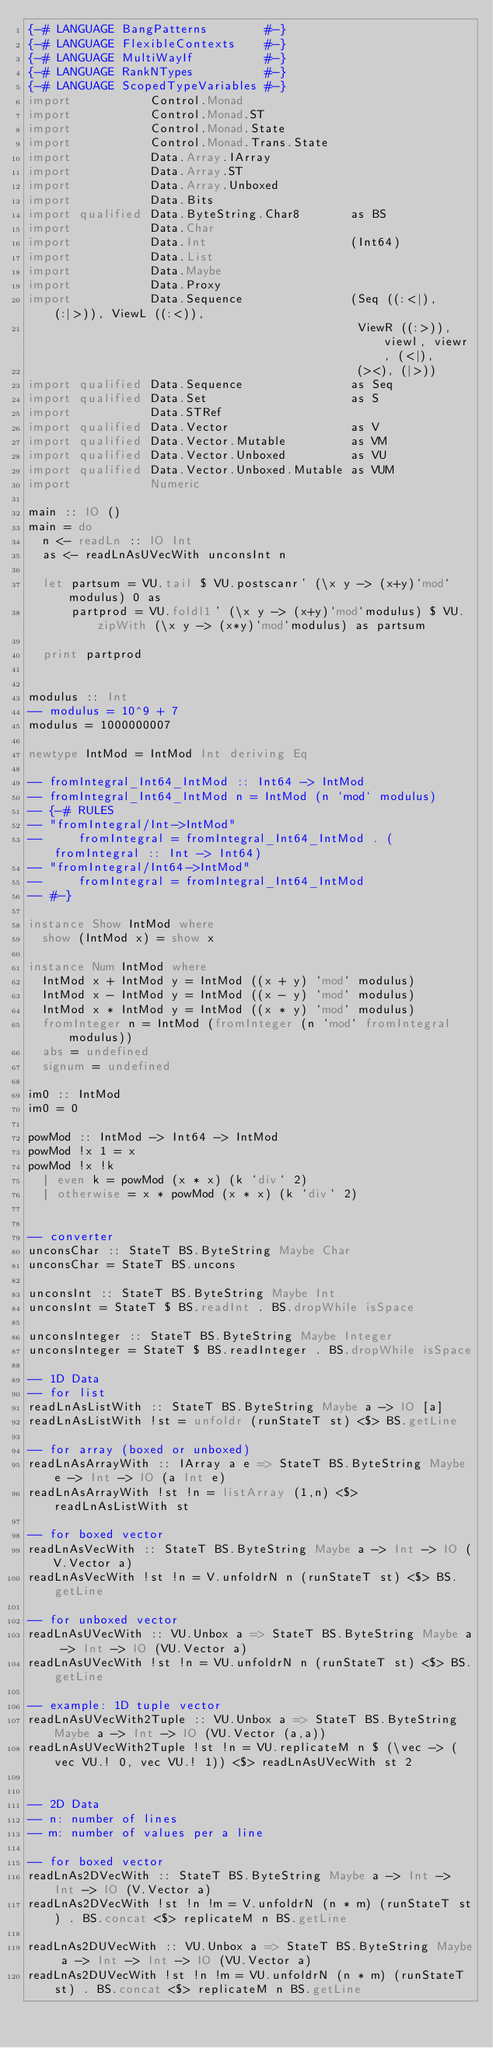Convert code to text. <code><loc_0><loc_0><loc_500><loc_500><_Haskell_>{-# LANGUAGE BangPatterns        #-}
{-# LANGUAGE FlexibleContexts    #-}
{-# LANGUAGE MultiWayIf          #-}
{-# LANGUAGE RankNTypes          #-}
{-# LANGUAGE ScopedTypeVariables #-}
import           Control.Monad
import           Control.Monad.ST
import           Control.Monad.State
import           Control.Monad.Trans.State
import           Data.Array.IArray
import           Data.Array.ST
import           Data.Array.Unboxed
import           Data.Bits
import qualified Data.ByteString.Char8       as BS
import           Data.Char
import           Data.Int                    (Int64)
import           Data.List
import           Data.Maybe
import           Data.Proxy
import           Data.Sequence               (Seq ((:<|), (:|>)), ViewL ((:<)),
                                              ViewR ((:>)), viewl, viewr, (<|),
                                              (><), (|>))
import qualified Data.Sequence               as Seq
import qualified Data.Set                    as S
import           Data.STRef
import qualified Data.Vector                 as V
import qualified Data.Vector.Mutable         as VM
import qualified Data.Vector.Unboxed         as VU
import qualified Data.Vector.Unboxed.Mutable as VUM
import           Numeric

main :: IO ()
main = do
  n <- readLn :: IO Int
  as <- readLnAsUVecWith unconsInt n

  let partsum = VU.tail $ VU.postscanr' (\x y -> (x+y)`mod`modulus) 0 as
      partprod = VU.foldl1' (\x y -> (x+y)`mod`modulus) $ VU.zipWith (\x y -> (x*y)`mod`modulus) as partsum

  print partprod


modulus :: Int
-- modulus = 10^9 + 7
modulus = 1000000007

newtype IntMod = IntMod Int deriving Eq

-- fromIntegral_Int64_IntMod :: Int64 -> IntMod
-- fromIntegral_Int64_IntMod n = IntMod (n `mod` modulus)
-- {-# RULES
-- "fromIntegral/Int->IntMod"
--     fromIntegral = fromIntegral_Int64_IntMod . (fromIntegral :: Int -> Int64)
-- "fromIntegral/Int64->IntMod"
--     fromIntegral = fromIntegral_Int64_IntMod
-- #-}

instance Show IntMod where
  show (IntMod x) = show x

instance Num IntMod where
  IntMod x + IntMod y = IntMod ((x + y) `mod` modulus)
  IntMod x - IntMod y = IntMod ((x - y) `mod` modulus)
  IntMod x * IntMod y = IntMod ((x * y) `mod` modulus)
  fromInteger n = IntMod (fromInteger (n `mod` fromIntegral modulus))
  abs = undefined
  signum = undefined

im0 :: IntMod
im0 = 0

powMod :: IntMod -> Int64 -> IntMod
powMod !x 1 = x
powMod !x !k
  | even k = powMod (x * x) (k `div` 2)
  | otherwise = x * powMod (x * x) (k `div` 2)


-- converter
unconsChar :: StateT BS.ByteString Maybe Char
unconsChar = StateT BS.uncons

unconsInt :: StateT BS.ByteString Maybe Int
unconsInt = StateT $ BS.readInt . BS.dropWhile isSpace

unconsInteger :: StateT BS.ByteString Maybe Integer
unconsInteger = StateT $ BS.readInteger . BS.dropWhile isSpace

-- 1D Data
-- for list
readLnAsListWith :: StateT BS.ByteString Maybe a -> IO [a]
readLnAsListWith !st = unfoldr (runStateT st) <$> BS.getLine

-- for array (boxed or unboxed)
readLnAsArrayWith :: IArray a e => StateT BS.ByteString Maybe e -> Int -> IO (a Int e)
readLnAsArrayWith !st !n = listArray (1,n) <$> readLnAsListWith st

-- for boxed vector
readLnAsVecWith :: StateT BS.ByteString Maybe a -> Int -> IO (V.Vector a)
readLnAsVecWith !st !n = V.unfoldrN n (runStateT st) <$> BS.getLine

-- for unboxed vector
readLnAsUVecWith :: VU.Unbox a => StateT BS.ByteString Maybe a -> Int -> IO (VU.Vector a)
readLnAsUVecWith !st !n = VU.unfoldrN n (runStateT st) <$> BS.getLine

-- example: 1D tuple vector
readLnAsUVecWith2Tuple :: VU.Unbox a => StateT BS.ByteString Maybe a -> Int -> IO (VU.Vector (a,a))
readLnAsUVecWith2Tuple !st !n = VU.replicateM n $ (\vec -> (vec VU.! 0, vec VU.! 1)) <$> readLnAsUVecWith st 2


-- 2D Data
-- n: number of lines
-- m: number of values per a line

-- for boxed vector
readLnAs2DVecWith :: StateT BS.ByteString Maybe a -> Int -> Int -> IO (V.Vector a)
readLnAs2DVecWith !st !n !m = V.unfoldrN (n * m) (runStateT st) . BS.concat <$> replicateM n BS.getLine

readLnAs2DUVecWith :: VU.Unbox a => StateT BS.ByteString Maybe a -> Int -> Int -> IO (VU.Vector a)
readLnAs2DUVecWith !st !n !m = VU.unfoldrN (n * m) (runStateT st) . BS.concat <$> replicateM n BS.getLine
</code> 